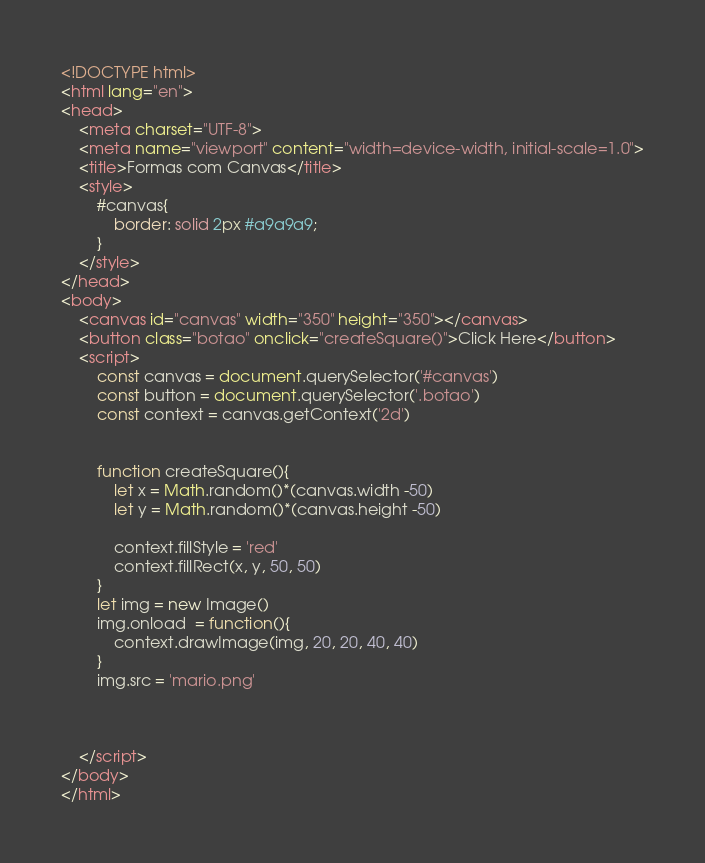<code> <loc_0><loc_0><loc_500><loc_500><_HTML_><!DOCTYPE html>
<html lang="en">
<head>
    <meta charset="UTF-8">
    <meta name="viewport" content="width=device-width, initial-scale=1.0">
    <title>Formas com Canvas</title>
    <style>
        #canvas{
            border: solid 2px #a9a9a9;
        }
    </style>
</head>
<body>
    <canvas id="canvas" width="350" height="350"></canvas>
    <button class="botao" onclick="createSquare()">Click Here</button>
    <script>
        const canvas = document.querySelector('#canvas')
        const button = document.querySelector('.botao')
        const context = canvas.getContext('2d')


        function createSquare(){
            let x = Math.random()*(canvas.width -50)
            let y = Math.random()*(canvas.height -50)
        
            context.fillStyle = 'red'
            context.fillRect(x, y, 50, 50)
        }
        let img = new Image()
        img.onload  = function(){
            context.drawImage(img, 20, 20, 40, 40)
        }
        img.src = 'mario.png'
        
        

    </script>
</body>
</html></code> 